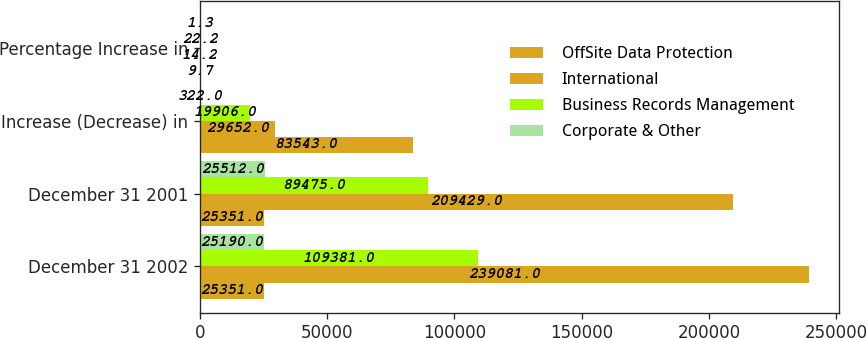Convert chart to OTSL. <chart><loc_0><loc_0><loc_500><loc_500><stacked_bar_chart><ecel><fcel>December 31 2002<fcel>December 31 2001<fcel>Increase (Decrease) in<fcel>Percentage Increase in<nl><fcel>OffSite Data Protection<fcel>25351<fcel>25351<fcel>83543<fcel>9.7<nl><fcel>International<fcel>239081<fcel>209429<fcel>29652<fcel>14.2<nl><fcel>Business Records Management<fcel>109381<fcel>89475<fcel>19906<fcel>22.2<nl><fcel>Corporate & Other<fcel>25190<fcel>25512<fcel>322<fcel>1.3<nl></chart> 